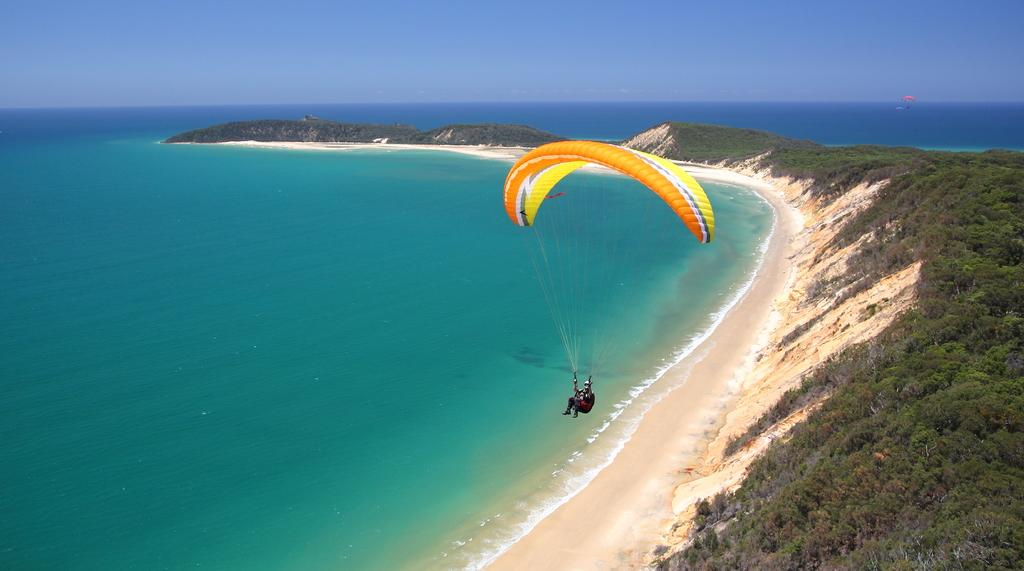What is the person in the image doing? The person is parachuting in the image. What is the person using to parachute? The person is using a parachute. What can be seen below the person in the image? There is water visible in the image. What else can be seen in the image besides the person and water? There are trees in the image, and there is another parachute visible. What is visible in the background of the image? The sky is visible in the background of the image. Where is the drain located in the image? There is no drain present in the image. What is the top of the parachute made of in the image? The provided facts do not specify the material of the parachute, so we cannot answer this question definitively. 